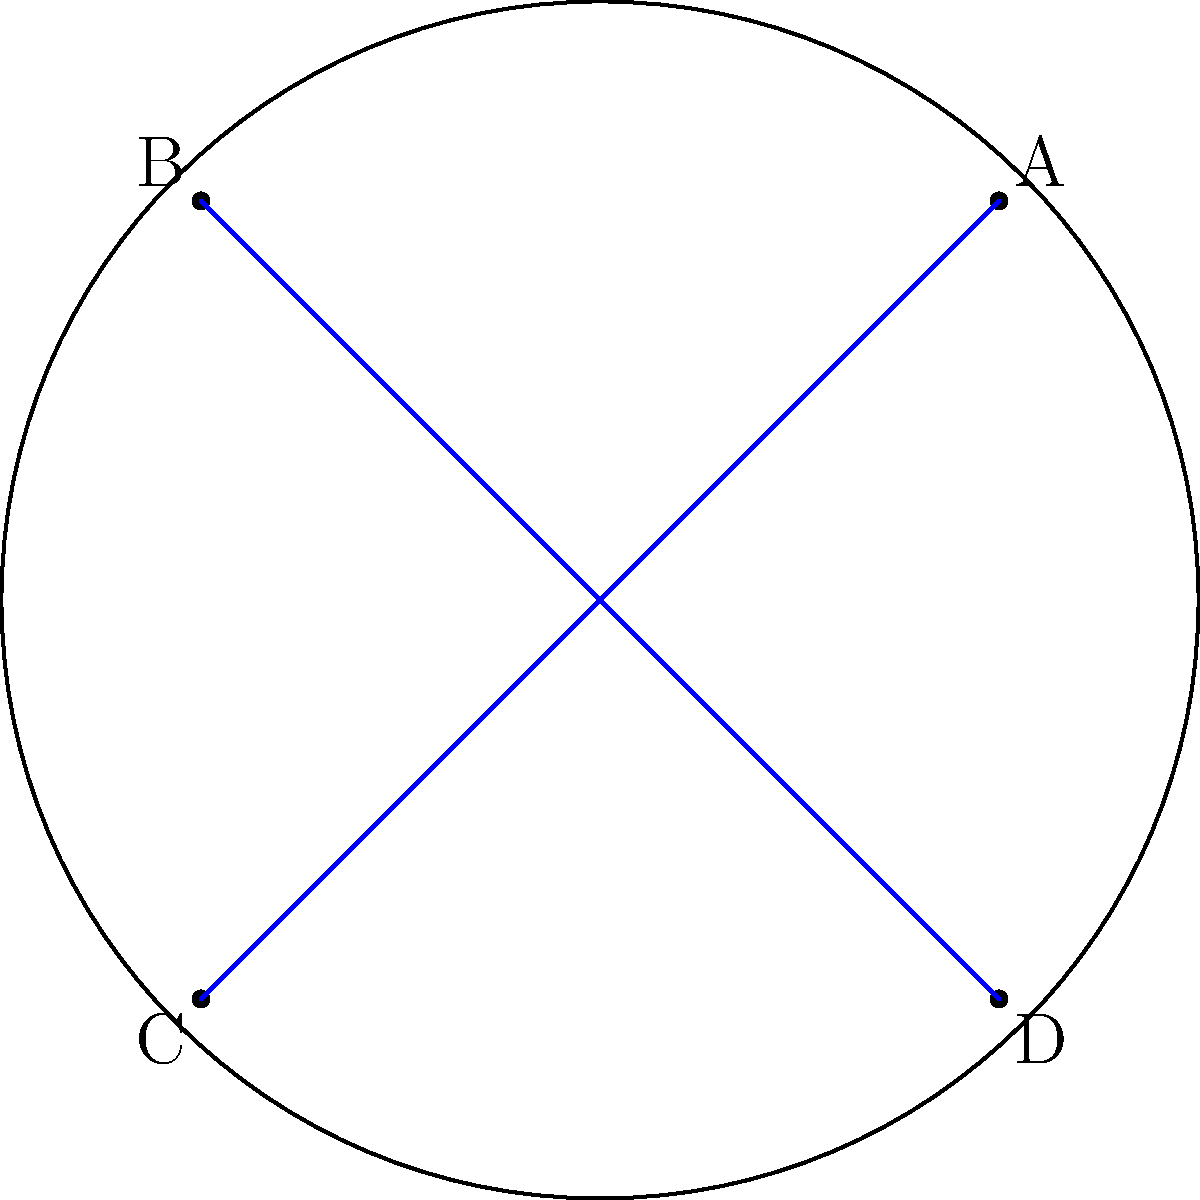In this hyperbolic disk model representing non-Euclidean geometry, the boundary circle represents infinity. If you were to spit some fresh rhymes while walking from point A to point C, which path would appear straight to you in this curved space, and why does it differ from what we see in the Euclidean plane? To understand this concept, let's break it down step-by-step:

1. In hyperbolic geometry, straight lines are represented by arcs that meet the boundary circle at right angles.

2. The path that appears straight to an observer in hyperbolic space is actually a curve in our Euclidean representation.

3. To find the "straight" path from A to C:
   a) We need to find the unique circle that passes through A and C and meets the boundary circle at right angles.
   b) This circle would appear as a straight line to an observer in hyperbolic space.

4. In the Euclidean plane, we'd expect the straight line to be the diameter AC. However, in hyperbolic geometry, this line curves towards the center of the disk.

5. This curvature is a result of the non-Euclidean nature of hyperbolic space, where parallel lines diverge and the sum of angles in a triangle is less than 180°.

6. The curved path represents the geodesic (shortest path) between A and C in hyperbolic space, analogous to how we perceive straight lines on the curved surface of the Earth.

7. This visualization demonstrates how space itself can be curved, a concept crucial in understanding non-Euclidean geometries and even aspects of general relativity in physics.
Answer: A curved arc perpendicular to the boundary circle 